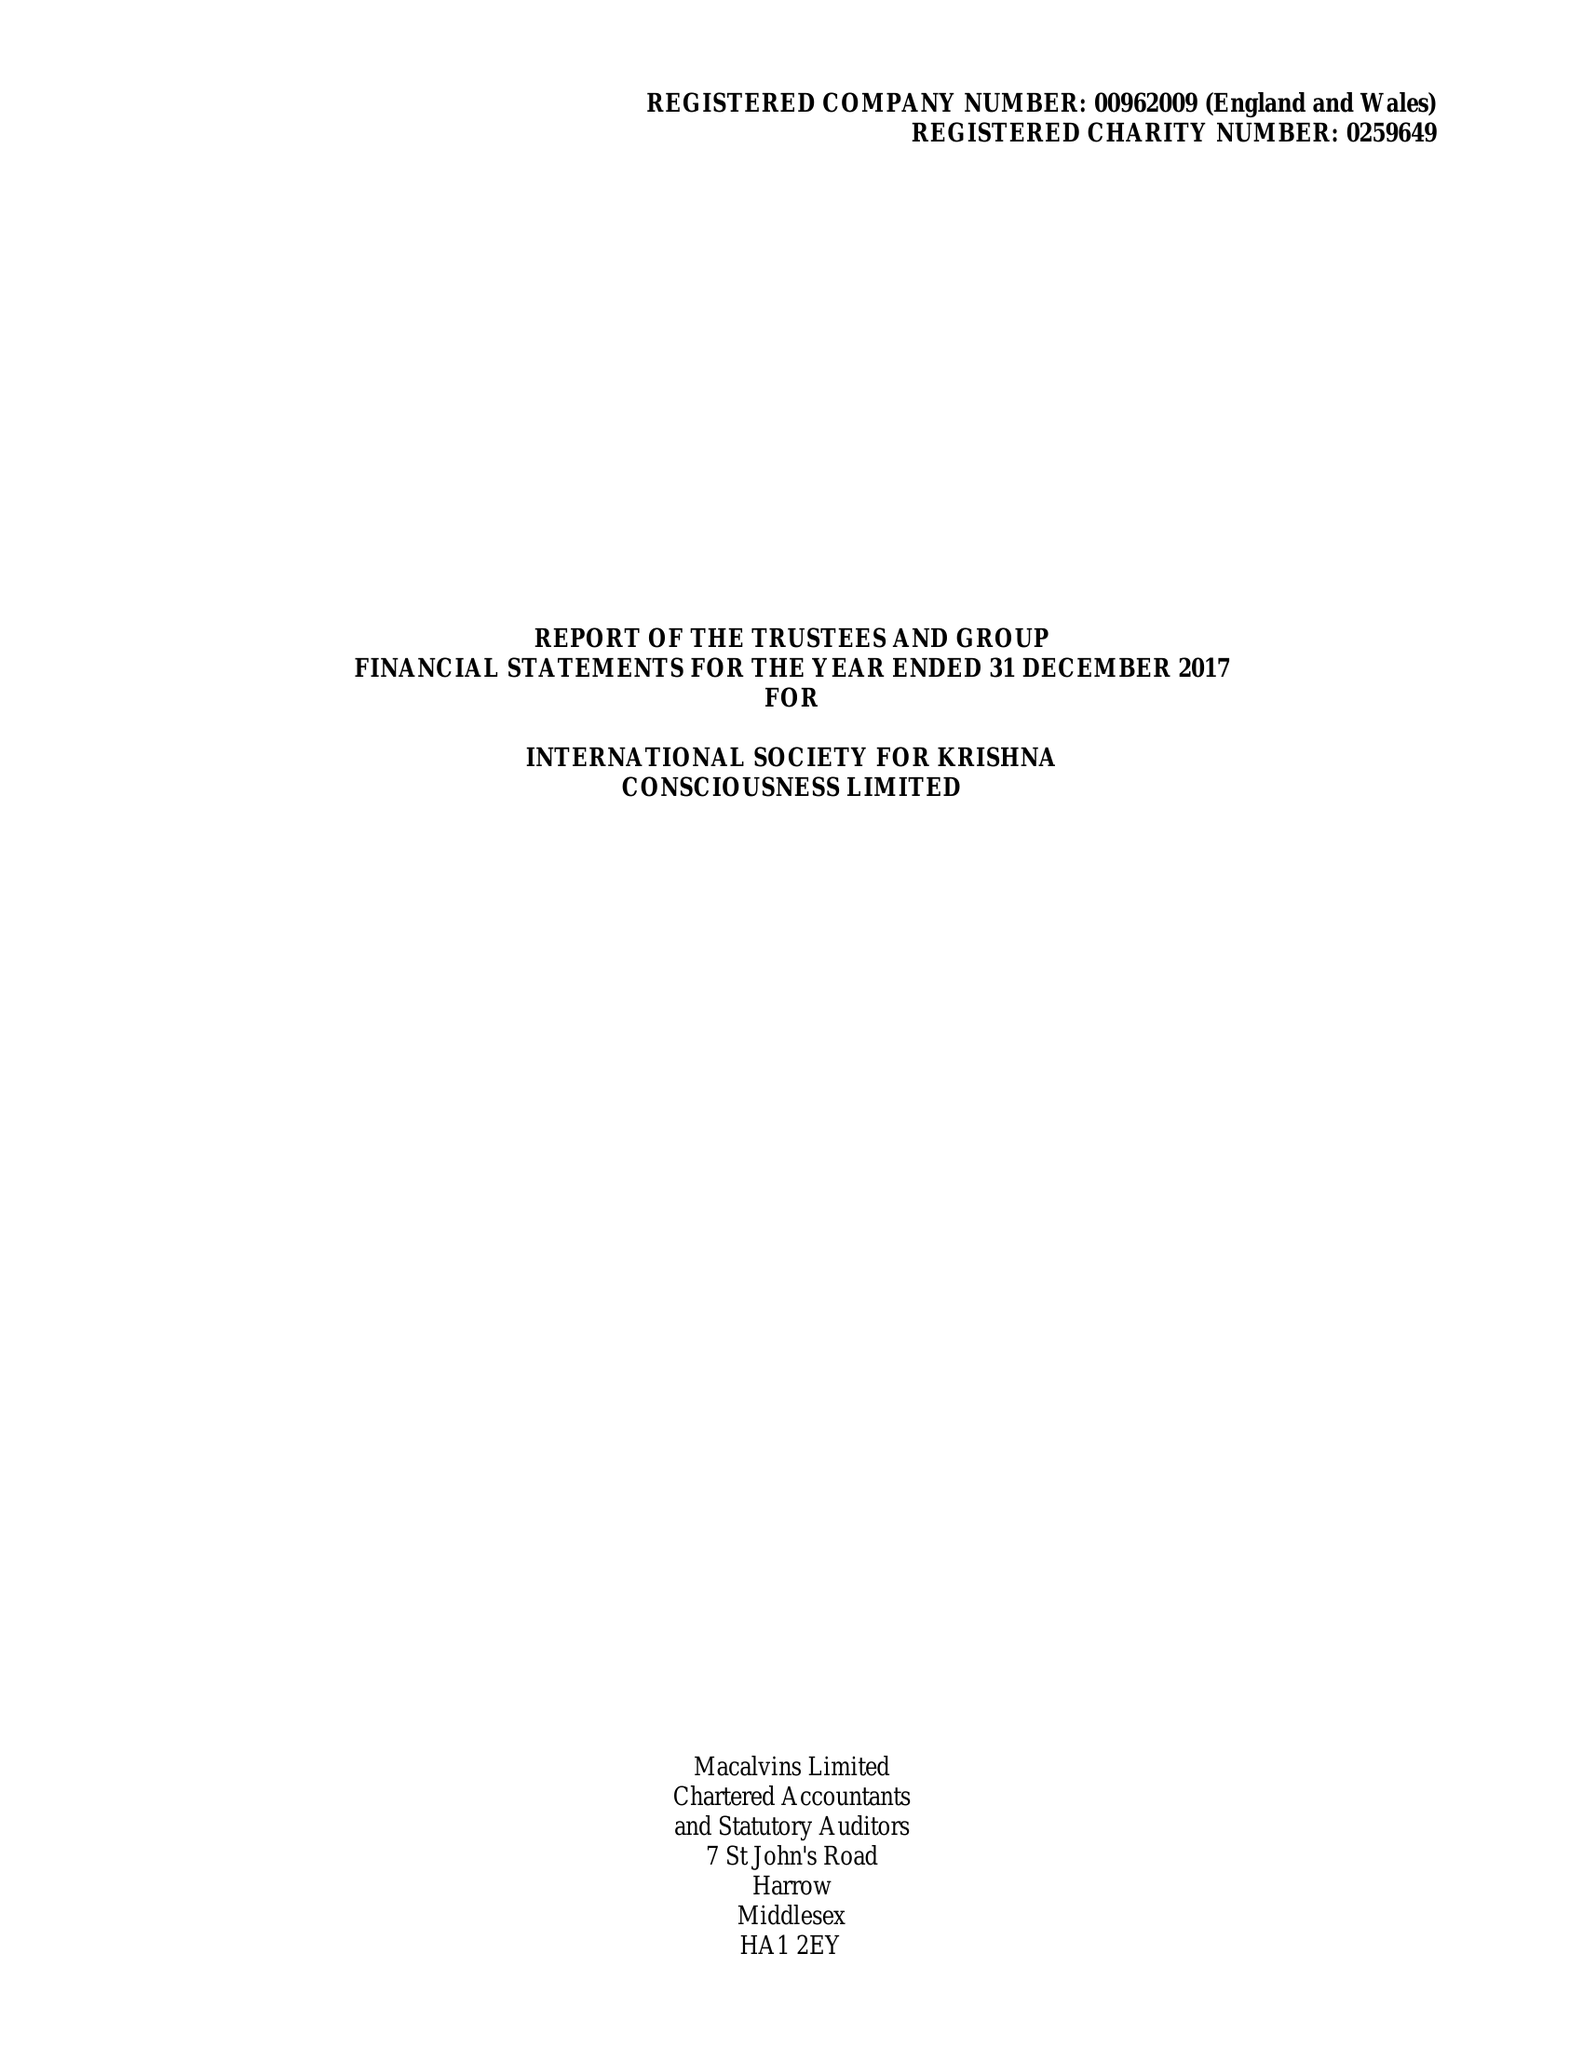What is the value for the address__post_town?
Answer the question using a single word or phrase. RADLETT 